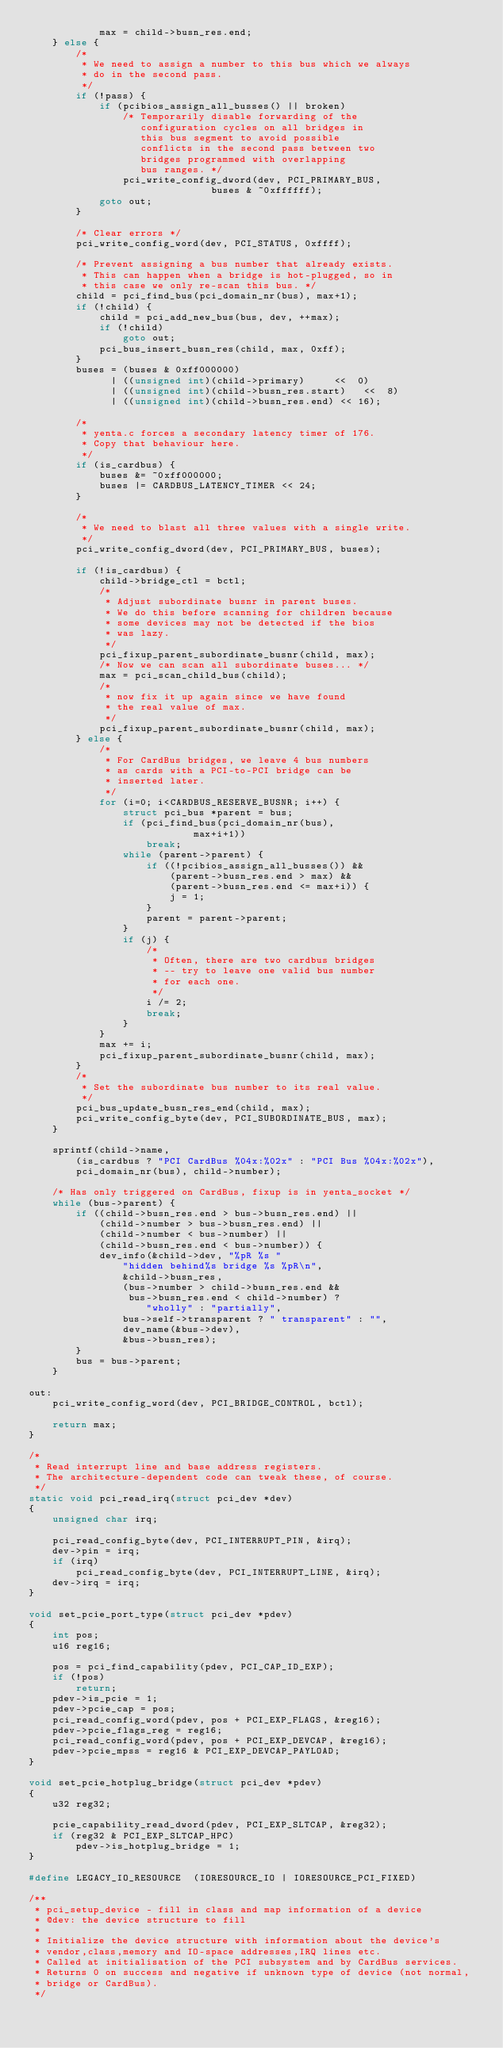<code> <loc_0><loc_0><loc_500><loc_500><_C_>			max = child->busn_res.end;
	} else {
		/*
		 * We need to assign a number to this bus which we always
		 * do in the second pass.
		 */
		if (!pass) {
			if (pcibios_assign_all_busses() || broken)
				/* Temporarily disable forwarding of the
				   configuration cycles on all bridges in
				   this bus segment to avoid possible
				   conflicts in the second pass between two
				   bridges programmed with overlapping
				   bus ranges. */
				pci_write_config_dword(dev, PCI_PRIMARY_BUS,
						       buses & ~0xffffff);
			goto out;
		}

		/* Clear errors */
		pci_write_config_word(dev, PCI_STATUS, 0xffff);

		/* Prevent assigning a bus number that already exists.
		 * This can happen when a bridge is hot-plugged, so in
		 * this case we only re-scan this bus. */
		child = pci_find_bus(pci_domain_nr(bus), max+1);
		if (!child) {
			child = pci_add_new_bus(bus, dev, ++max);
			if (!child)
				goto out;
			pci_bus_insert_busn_res(child, max, 0xff);
		}
		buses = (buses & 0xff000000)
		      | ((unsigned int)(child->primary)     <<  0)
		      | ((unsigned int)(child->busn_res.start)   <<  8)
		      | ((unsigned int)(child->busn_res.end) << 16);

		/*
		 * yenta.c forces a secondary latency timer of 176.
		 * Copy that behaviour here.
		 */
		if (is_cardbus) {
			buses &= ~0xff000000;
			buses |= CARDBUS_LATENCY_TIMER << 24;
		}

		/*
		 * We need to blast all three values with a single write.
		 */
		pci_write_config_dword(dev, PCI_PRIMARY_BUS, buses);

		if (!is_cardbus) {
			child->bridge_ctl = bctl;
			/*
			 * Adjust subordinate busnr in parent buses.
			 * We do this before scanning for children because
			 * some devices may not be detected if the bios
			 * was lazy.
			 */
			pci_fixup_parent_subordinate_busnr(child, max);
			/* Now we can scan all subordinate buses... */
			max = pci_scan_child_bus(child);
			/*
			 * now fix it up again since we have found
			 * the real value of max.
			 */
			pci_fixup_parent_subordinate_busnr(child, max);
		} else {
			/*
			 * For CardBus bridges, we leave 4 bus numbers
			 * as cards with a PCI-to-PCI bridge can be
			 * inserted later.
			 */
			for (i=0; i<CARDBUS_RESERVE_BUSNR; i++) {
				struct pci_bus *parent = bus;
				if (pci_find_bus(pci_domain_nr(bus),
							max+i+1))
					break;
				while (parent->parent) {
					if ((!pcibios_assign_all_busses()) &&
					    (parent->busn_res.end > max) &&
					    (parent->busn_res.end <= max+i)) {
						j = 1;
					}
					parent = parent->parent;
				}
				if (j) {
					/*
					 * Often, there are two cardbus bridges
					 * -- try to leave one valid bus number
					 * for each one.
					 */
					i /= 2;
					break;
				}
			}
			max += i;
			pci_fixup_parent_subordinate_busnr(child, max);
		}
		/*
		 * Set the subordinate bus number to its real value.
		 */
		pci_bus_update_busn_res_end(child, max);
		pci_write_config_byte(dev, PCI_SUBORDINATE_BUS, max);
	}

	sprintf(child->name,
		(is_cardbus ? "PCI CardBus %04x:%02x" : "PCI Bus %04x:%02x"),
		pci_domain_nr(bus), child->number);

	/* Has only triggered on CardBus, fixup is in yenta_socket */
	while (bus->parent) {
		if ((child->busn_res.end > bus->busn_res.end) ||
		    (child->number > bus->busn_res.end) ||
		    (child->number < bus->number) ||
		    (child->busn_res.end < bus->number)) {
			dev_info(&child->dev, "%pR %s "
				"hidden behind%s bridge %s %pR\n",
				&child->busn_res,
				(bus->number > child->busn_res.end &&
				 bus->busn_res.end < child->number) ?
					"wholly" : "partially",
				bus->self->transparent ? " transparent" : "",
				dev_name(&bus->dev),
				&bus->busn_res);
		}
		bus = bus->parent;
	}

out:
	pci_write_config_word(dev, PCI_BRIDGE_CONTROL, bctl);

	return max;
}

/*
 * Read interrupt line and base address registers.
 * The architecture-dependent code can tweak these, of course.
 */
static void pci_read_irq(struct pci_dev *dev)
{
	unsigned char irq;

	pci_read_config_byte(dev, PCI_INTERRUPT_PIN, &irq);
	dev->pin = irq;
	if (irq)
		pci_read_config_byte(dev, PCI_INTERRUPT_LINE, &irq);
	dev->irq = irq;
}

void set_pcie_port_type(struct pci_dev *pdev)
{
	int pos;
	u16 reg16;

	pos = pci_find_capability(pdev, PCI_CAP_ID_EXP);
	if (!pos)
		return;
	pdev->is_pcie = 1;
	pdev->pcie_cap = pos;
	pci_read_config_word(pdev, pos + PCI_EXP_FLAGS, &reg16);
	pdev->pcie_flags_reg = reg16;
	pci_read_config_word(pdev, pos + PCI_EXP_DEVCAP, &reg16);
	pdev->pcie_mpss = reg16 & PCI_EXP_DEVCAP_PAYLOAD;
}

void set_pcie_hotplug_bridge(struct pci_dev *pdev)
{
	u32 reg32;

	pcie_capability_read_dword(pdev, PCI_EXP_SLTCAP, &reg32);
	if (reg32 & PCI_EXP_SLTCAP_HPC)
		pdev->is_hotplug_bridge = 1;
}

#define LEGACY_IO_RESOURCE	(IORESOURCE_IO | IORESOURCE_PCI_FIXED)

/**
 * pci_setup_device - fill in class and map information of a device
 * @dev: the device structure to fill
 *
 * Initialize the device structure with information about the device's 
 * vendor,class,memory and IO-space addresses,IRQ lines etc.
 * Called at initialisation of the PCI subsystem and by CardBus services.
 * Returns 0 on success and negative if unknown type of device (not normal,
 * bridge or CardBus).
 */</code> 